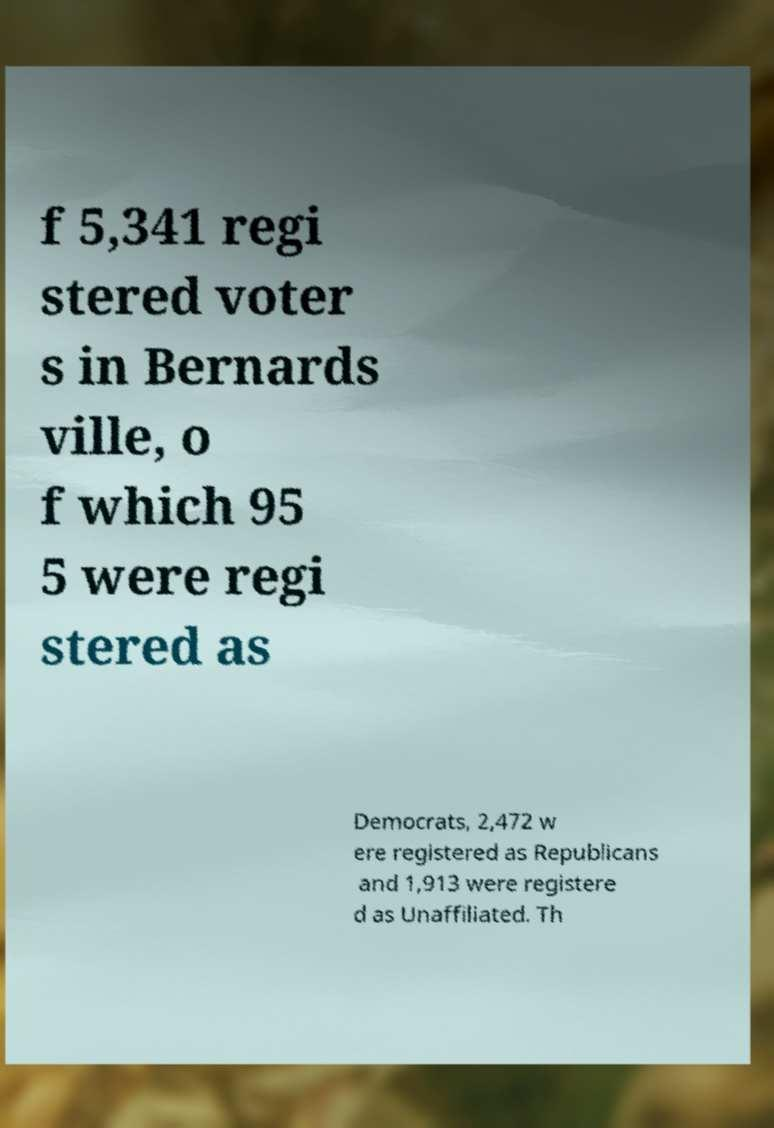Can you accurately transcribe the text from the provided image for me? f 5,341 regi stered voter s in Bernards ville, o f which 95 5 were regi stered as Democrats, 2,472 w ere registered as Republicans and 1,913 were registere d as Unaffiliated. Th 